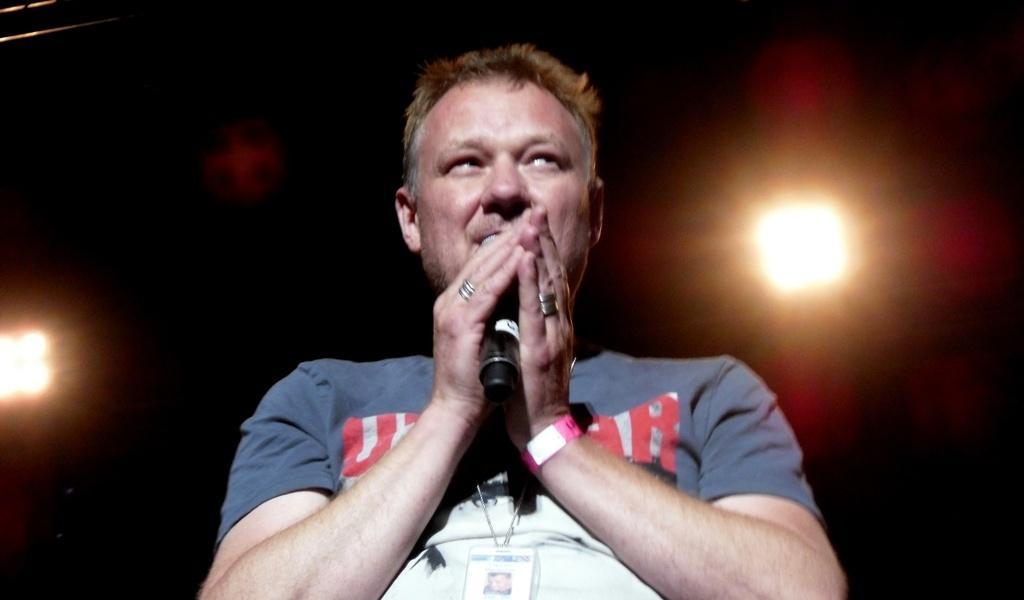Can you describe this image briefly? In this image I can see the person with the white and grey color t-shirt and the person holding the mic. In the background I can see some lights. 